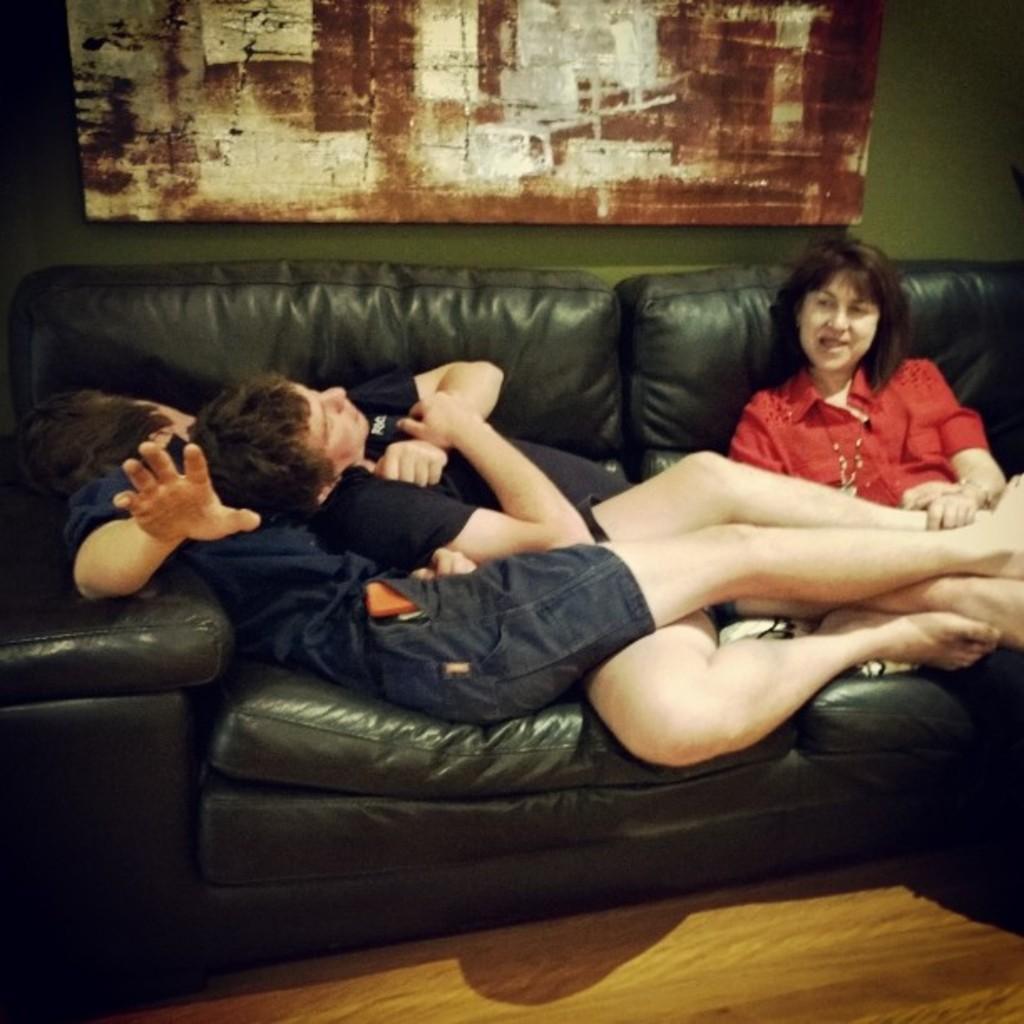Please provide a concise description of this image. The black shirt person and blue shirt person slept on a black sofa and kept their legs on the laps of a person who is wearing red shirt and the background wall is green in color and there is some painting on the wall. 